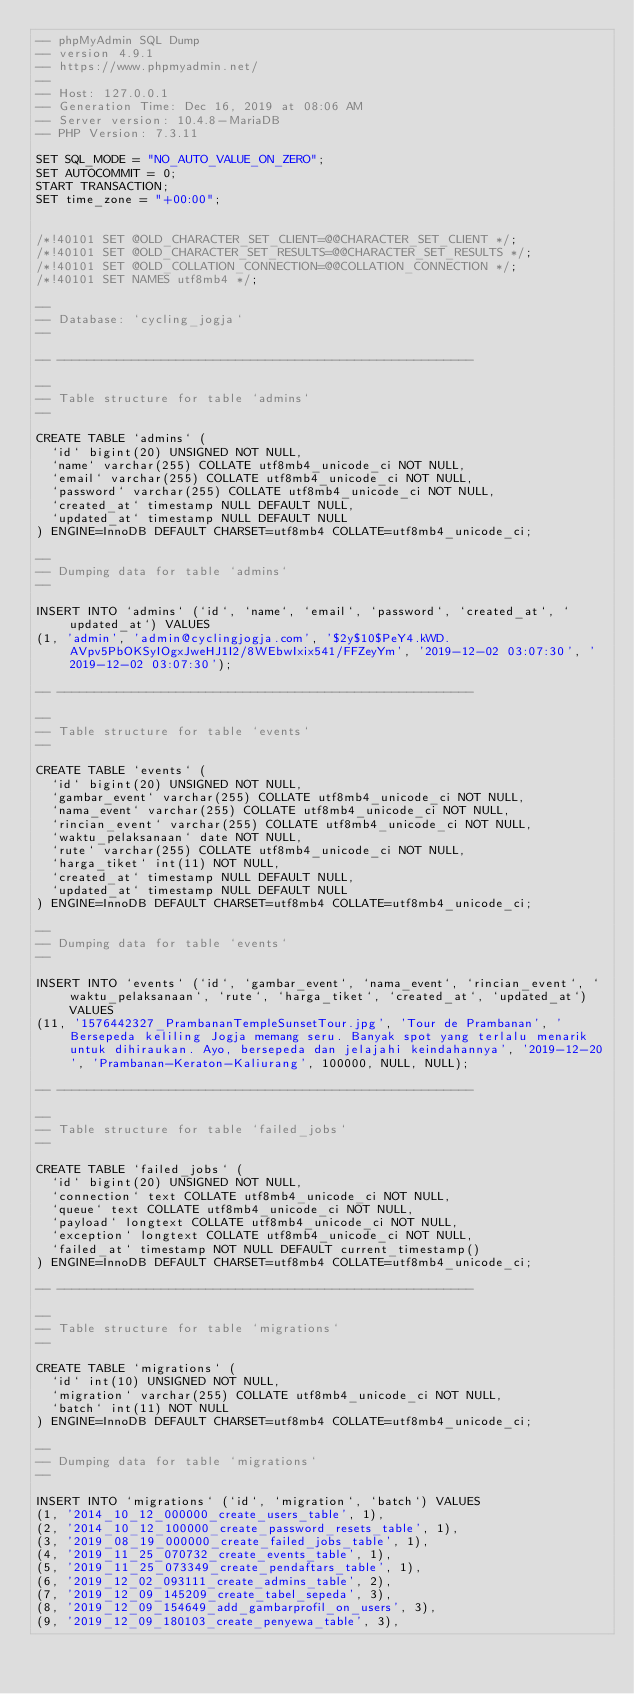<code> <loc_0><loc_0><loc_500><loc_500><_SQL_>-- phpMyAdmin SQL Dump
-- version 4.9.1
-- https://www.phpmyadmin.net/
--
-- Host: 127.0.0.1
-- Generation Time: Dec 16, 2019 at 08:06 AM
-- Server version: 10.4.8-MariaDB
-- PHP Version: 7.3.11

SET SQL_MODE = "NO_AUTO_VALUE_ON_ZERO";
SET AUTOCOMMIT = 0;
START TRANSACTION;
SET time_zone = "+00:00";


/*!40101 SET @OLD_CHARACTER_SET_CLIENT=@@CHARACTER_SET_CLIENT */;
/*!40101 SET @OLD_CHARACTER_SET_RESULTS=@@CHARACTER_SET_RESULTS */;
/*!40101 SET @OLD_COLLATION_CONNECTION=@@COLLATION_CONNECTION */;
/*!40101 SET NAMES utf8mb4 */;

--
-- Database: `cycling_jogja`
--

-- --------------------------------------------------------

--
-- Table structure for table `admins`
--

CREATE TABLE `admins` (
  `id` bigint(20) UNSIGNED NOT NULL,
  `name` varchar(255) COLLATE utf8mb4_unicode_ci NOT NULL,
  `email` varchar(255) COLLATE utf8mb4_unicode_ci NOT NULL,
  `password` varchar(255) COLLATE utf8mb4_unicode_ci NOT NULL,
  `created_at` timestamp NULL DEFAULT NULL,
  `updated_at` timestamp NULL DEFAULT NULL
) ENGINE=InnoDB DEFAULT CHARSET=utf8mb4 COLLATE=utf8mb4_unicode_ci;

--
-- Dumping data for table `admins`
--

INSERT INTO `admins` (`id`, `name`, `email`, `password`, `created_at`, `updated_at`) VALUES
(1, 'admin', 'admin@cyclingjogja.com', '$2y$10$PeY4.kWD.AVpv5PbOKSyIOgxJweHJ1I2/8WEbwIxix541/FFZeyYm', '2019-12-02 03:07:30', '2019-12-02 03:07:30');

-- --------------------------------------------------------

--
-- Table structure for table `events`
--

CREATE TABLE `events` (
  `id` bigint(20) UNSIGNED NOT NULL,
  `gambar_event` varchar(255) COLLATE utf8mb4_unicode_ci NOT NULL,
  `nama_event` varchar(255) COLLATE utf8mb4_unicode_ci NOT NULL,
  `rincian_event` varchar(255) COLLATE utf8mb4_unicode_ci NOT NULL,
  `waktu_pelaksanaan` date NOT NULL,
  `rute` varchar(255) COLLATE utf8mb4_unicode_ci NOT NULL,
  `harga_tiket` int(11) NOT NULL,
  `created_at` timestamp NULL DEFAULT NULL,
  `updated_at` timestamp NULL DEFAULT NULL
) ENGINE=InnoDB DEFAULT CHARSET=utf8mb4 COLLATE=utf8mb4_unicode_ci;

--
-- Dumping data for table `events`
--

INSERT INTO `events` (`id`, `gambar_event`, `nama_event`, `rincian_event`, `waktu_pelaksanaan`, `rute`, `harga_tiket`, `created_at`, `updated_at`) VALUES
(11, '1576442327_PrambananTempleSunsetTour.jpg', 'Tour de Prambanan', 'Bersepeda keliling Jogja memang seru. Banyak spot yang terlalu menarik untuk dihiraukan. Ayo, bersepeda dan jelajahi keindahannya', '2019-12-20', 'Prambanan-Keraton-Kaliurang', 100000, NULL, NULL);

-- --------------------------------------------------------

--
-- Table structure for table `failed_jobs`
--

CREATE TABLE `failed_jobs` (
  `id` bigint(20) UNSIGNED NOT NULL,
  `connection` text COLLATE utf8mb4_unicode_ci NOT NULL,
  `queue` text COLLATE utf8mb4_unicode_ci NOT NULL,
  `payload` longtext COLLATE utf8mb4_unicode_ci NOT NULL,
  `exception` longtext COLLATE utf8mb4_unicode_ci NOT NULL,
  `failed_at` timestamp NOT NULL DEFAULT current_timestamp()
) ENGINE=InnoDB DEFAULT CHARSET=utf8mb4 COLLATE=utf8mb4_unicode_ci;

-- --------------------------------------------------------

--
-- Table structure for table `migrations`
--

CREATE TABLE `migrations` (
  `id` int(10) UNSIGNED NOT NULL,
  `migration` varchar(255) COLLATE utf8mb4_unicode_ci NOT NULL,
  `batch` int(11) NOT NULL
) ENGINE=InnoDB DEFAULT CHARSET=utf8mb4 COLLATE=utf8mb4_unicode_ci;

--
-- Dumping data for table `migrations`
--

INSERT INTO `migrations` (`id`, `migration`, `batch`) VALUES
(1, '2014_10_12_000000_create_users_table', 1),
(2, '2014_10_12_100000_create_password_resets_table', 1),
(3, '2019_08_19_000000_create_failed_jobs_table', 1),
(4, '2019_11_25_070732_create_events_table', 1),
(5, '2019_11_25_073349_create_pendaftars_table', 1),
(6, '2019_12_02_093111_create_admins_table', 2),
(7, '2019_12_09_145209_create_tabel_sepeda', 3),
(8, '2019_12_09_154649_add_gambarprofil_on_users', 3),
(9, '2019_12_09_180103_create_penyewa_table', 3),</code> 